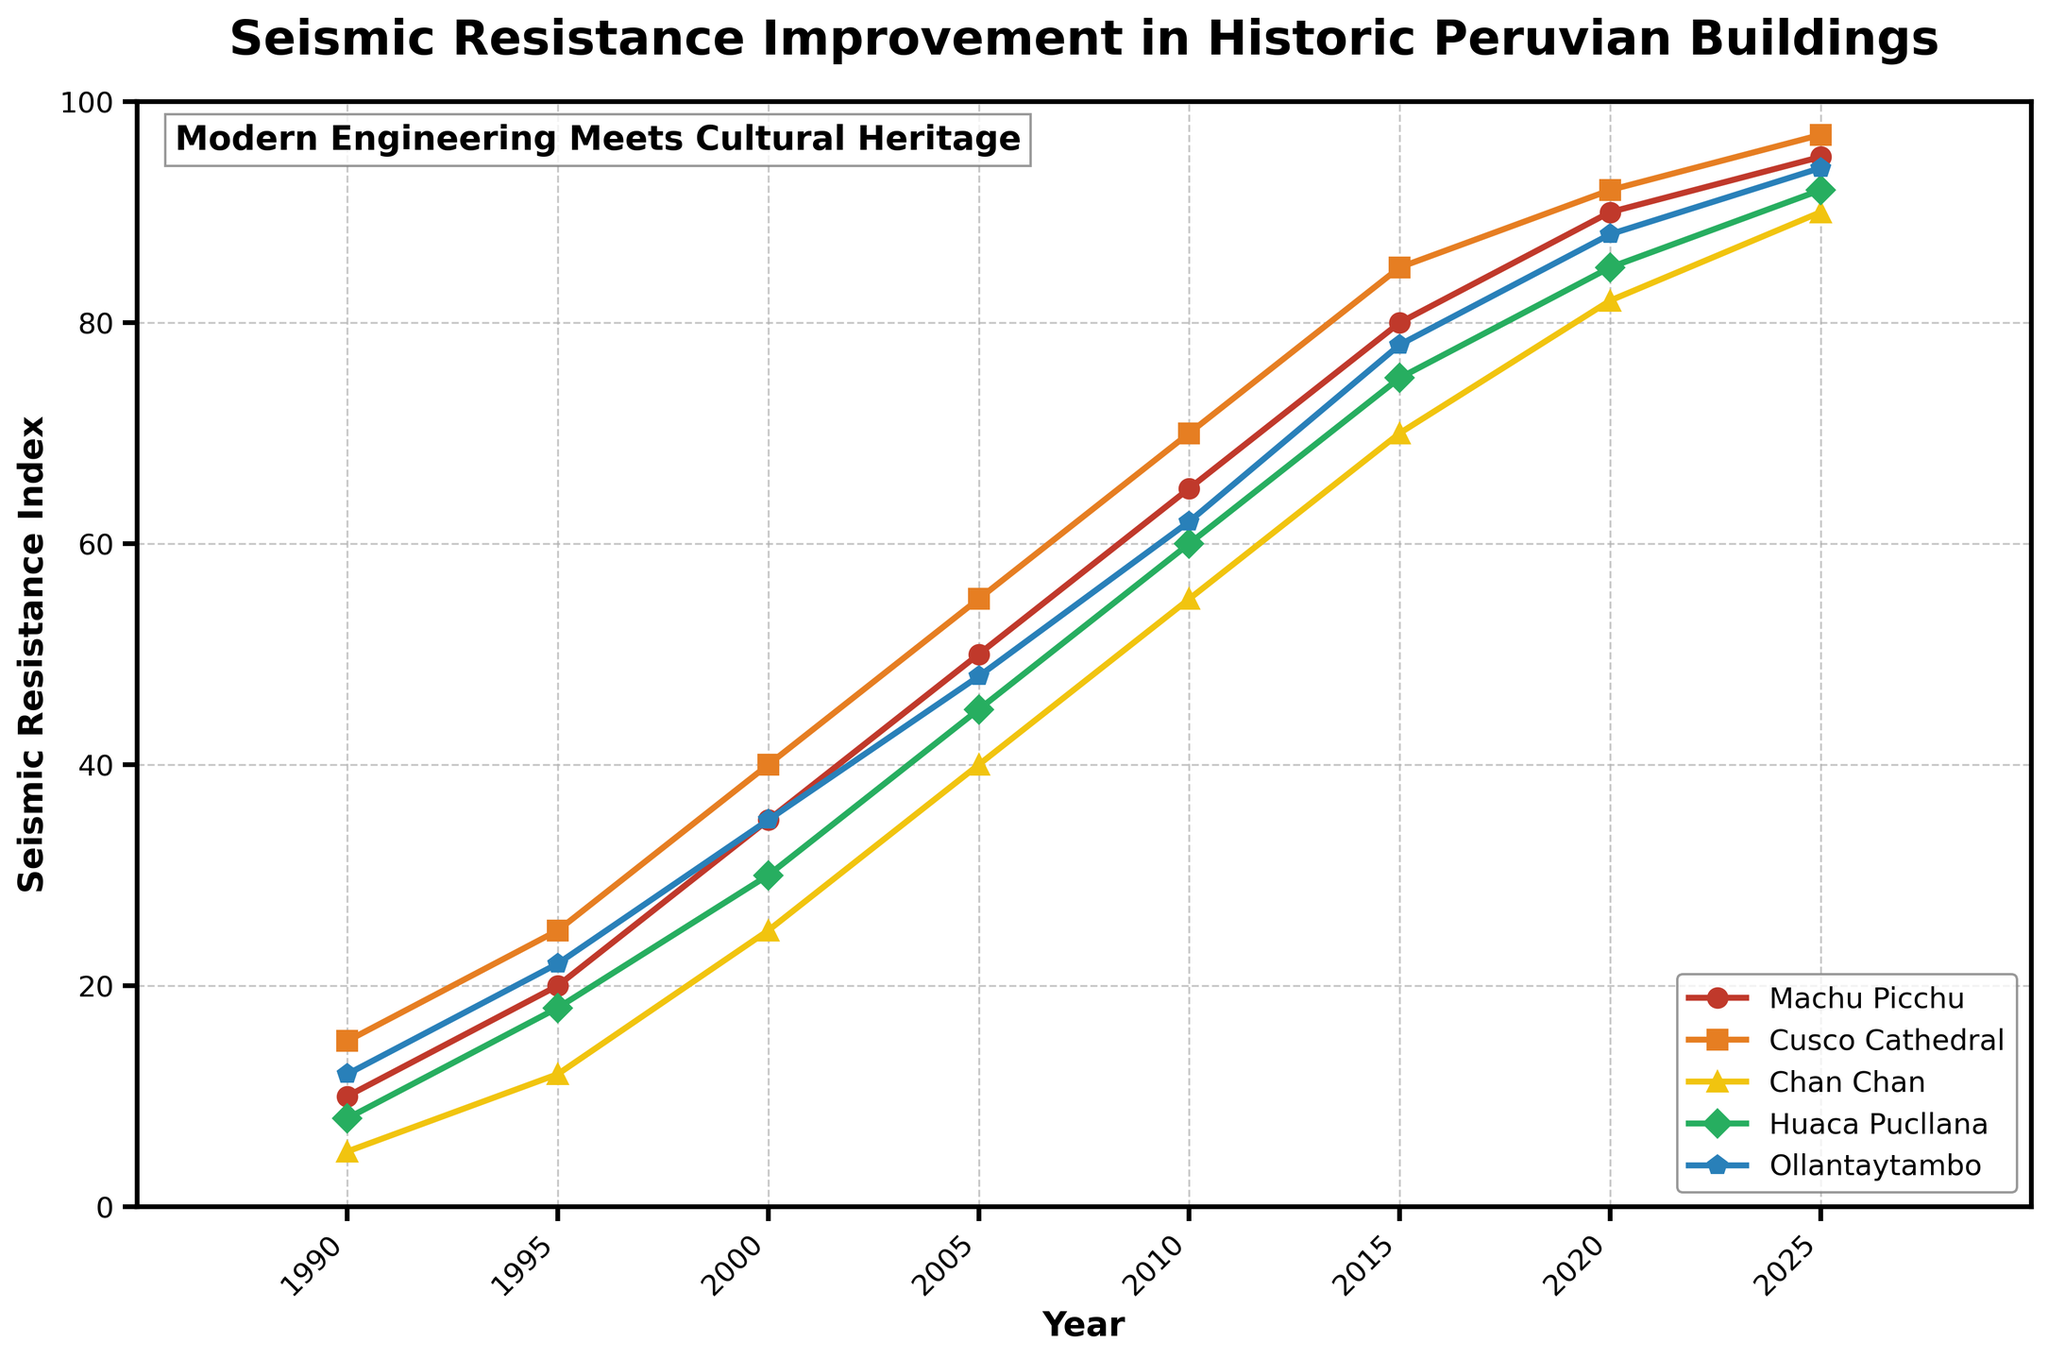What's the average seismic resistance index for Machu Picchu across all years? Calculate the average by summing all the seismic resistance indices for Machu Picchu and dividing by the total number of years: (10 + 20 + 35 + 50 + 65 + 80 + 90 + 95) / 8 = 55.625
Answer: 55.625 Which building had the highest seismic resistance index in the year 2020? Look for the highest value in the year 2020 column. The seismic resistance indices in 2020 were Machu Picchu (90), Cusco Cathedral (92), Chan Chan (82), Huaca Pucllana (85), and Ollantaytambo (88). Cusco Cathedral had the highest value.
Answer: Cusco Cathedral By how much did the seismic resistance index of Chan Chan increase from 1990 to 2000? Subtract the seismic resistance index of 1990 from that of 2000 for Chan Chan: 25 - 5 = 20.
Answer: 20 Which building showed the most significant improvement in seismic resistance between 1990 and 2025? Calculate the difference in seismic resistance indices between 1990 and 2025 for each building, and find the building with the highest difference. Machu Picchu (95-10=85), Cusco Cathedral (97-15=82), Chan Chan (90-5=85), Huaca Pucllana (92-8=84), and Ollantaytambo (94-12=82). Both Machu Picchu and Chan Chan showed the highest improvement of 85.
Answer: Machu Picchu and Chan Chan In what year did Huaca Pucllana first surpass a seismic resistance index of 50? Locate the year in which Huaca Pucllana's seismic resistance index first exceeded 50. The indices are: 1990 (8), 1995 (18), 2000 (30), 2005 (45), 2010 (60). In 2010, the index first surpassed 50.
Answer: 2010 Which two buildings had the closest seismic resistance index values in 2015? Compare the seismic resistance index values in 2015 and find the two closest values. The indices are: Machu Picchu (80), Cusco Cathedral (85), Chan Chan (70), Huaca Pucllana (75), and Ollantaytambo (78). The closest values are Huaca Pucllana (75) and Ollantaytambo (78).
Answer: Huaca Pucllana and Ollantaytambo What is the total increase in seismic resistance index for Cusco Cathedral from 1990 to 2025? Calculate the total increase by subtracting the seismic resistance index of 1990 from that of 2025 for Cusco Cathedral: 97 - 15 = 82.
Answer: 82 Did any building have its seismic resistance index more than double between 1990 and 2010? If so, which ones? For each building, check if the seismic resistance index in 2010 is more than twice the index in 1990. Machu Picchu: 65 > 20 (2*10), Cusco Cathedral: 70 > 30 (2*15), Chan Chan: 55 > 10 (2*5), Huaca Pucllana: 60 > 16 (2*8), Ollantaytambo: 62 > 24 (2*12). All buildings except Cusco Cathedral more than doubled their index.
Answer: Machu Picchu, Chan Chan, Huaca Pucllana, Ollantaytambo How does the trend of seismic resistance improvement compare between Machu Picchu and Ollantaytambo from 1990 to 2025? Observe the trend lines for Machu Picchu and Ollantaytambo. Both show a steady increase over the years, but Machu Picchu starts with a lower index in 1990 and shows a slightly steeper improvement, especially post-2000.
Answer: Machu Picchu has a steeper improvement trend What is the average yearly increase in seismic resistance for Huaca Pucllana from 1990 to 2025? Calculate the total increase from 1990 to 2025, then divide by the number of years (2025-1990). Total increase: 92 - 8 = 84. Number of years: 2025 - 1990 = 35. Average yearly increase: 84 / 35 = 2.4.
Answer: 2.4 